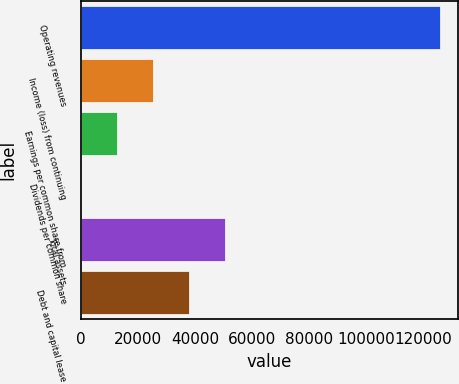Convert chart to OTSL. <chart><loc_0><loc_0><loc_500><loc_500><bar_chart><fcel>Operating revenues<fcel>Income (loss) from continuing<fcel>Earnings per common share from<fcel>Dividends per common share<fcel>Total assets<fcel>Debt and capital lease<nl><fcel>125987<fcel>25197.6<fcel>12599<fcel>0.3<fcel>50395<fcel>37796.3<nl></chart> 